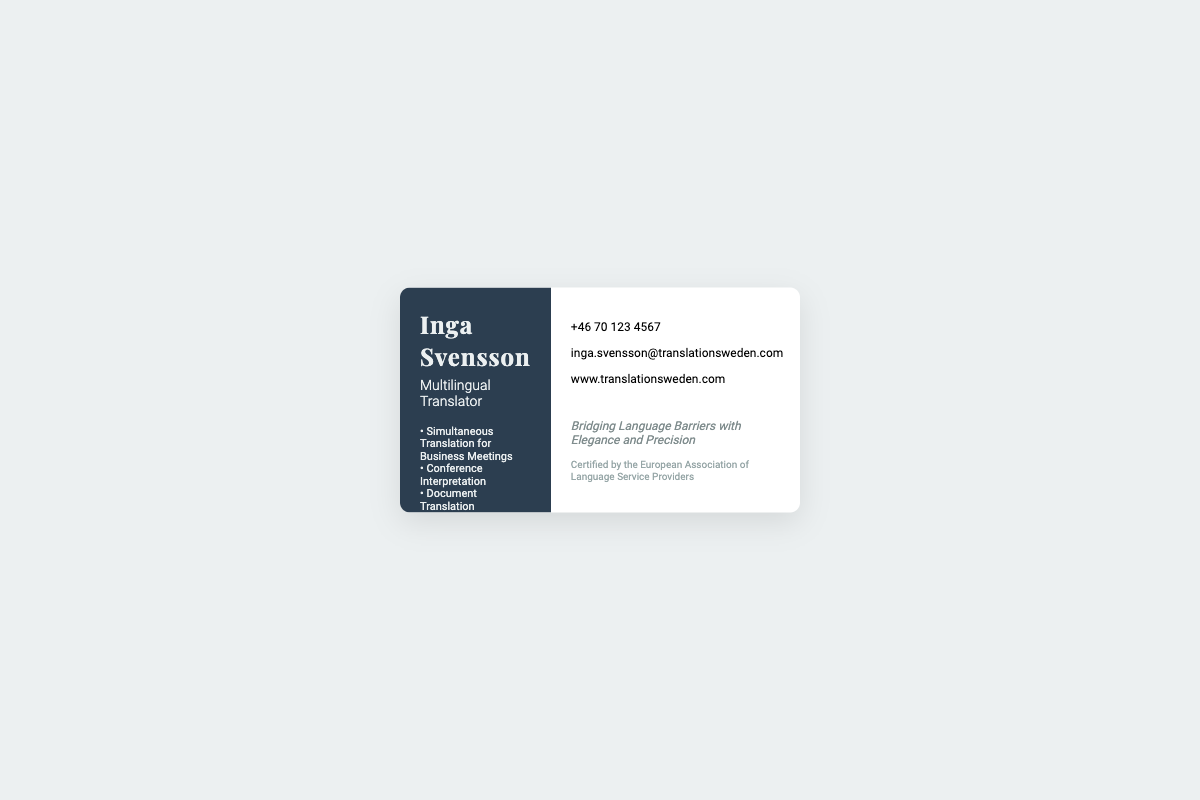What is Inga's profession? Inga's profession is displayed prominently on the business card as "Multilingual Translator."
Answer: Multilingual Translator What services does Inga offer? The business card lists several services offered by Inga, including translation and interpretation services.
Answer: Simultaneous Translation for Business Meetings, Conference Interpretation, Document Translation, Cultural Consultation What is Inga's phone number? The business card provides a contact number for Inga.
Answer: +46 70 123 4567 What is the website for Inga's services? The business card includes a web address for potential clients to visit for more information.
Answer: www.translationsweden.com Who certified Inga's services? There is a note on the business card indicating her certification.
Answer: European Association of Language Service Providers What is the tagline on the business card? The tagline summarizing Inga's service philosophy is also included in the document.
Answer: Bridging Language Barriers with Elegance and Precision What percentage of the business card features Inga's name? The left side of the card displays Inga's name and profession, indicating a design choice emphasizing her identity.
Answer: 40% What font style is used for Inga's name? The document specifies a particular font style used for Inga's name that adds elegance to the design.
Answer: Playfair Display What color is the background of the left side of the card? The color scheme of the business card shows that the left side is designed with a specific background color.
Answer: #2c3e50 